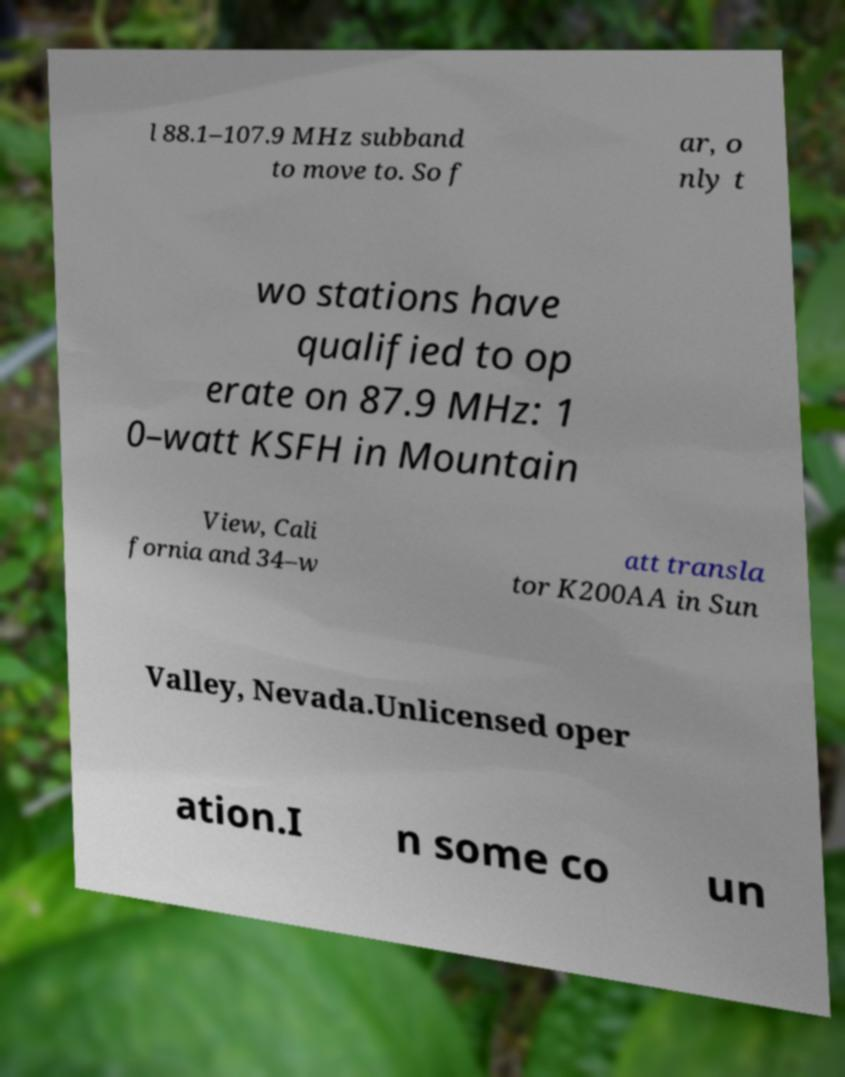Can you accurately transcribe the text from the provided image for me? l 88.1–107.9 MHz subband to move to. So f ar, o nly t wo stations have qualified to op erate on 87.9 MHz: 1 0–watt KSFH in Mountain View, Cali fornia and 34–w att transla tor K200AA in Sun Valley, Nevada.Unlicensed oper ation.I n some co un 